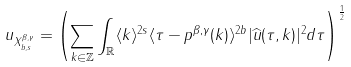Convert formula to latex. <formula><loc_0><loc_0><loc_500><loc_500>\| u \| _ { X _ { b , s } ^ { \beta , \gamma } } = \left ( \sum _ { k \in \mathbb { Z } } \int _ { \mathbb { R } } \langle k \rangle ^ { 2 s } \langle \tau - p ^ { \beta , \gamma } ( k ) \rangle ^ { 2 b } | \widehat { u } ( \tau , k ) | ^ { 2 } d \tau \right ) ^ { \frac { 1 } { 2 } }</formula> 